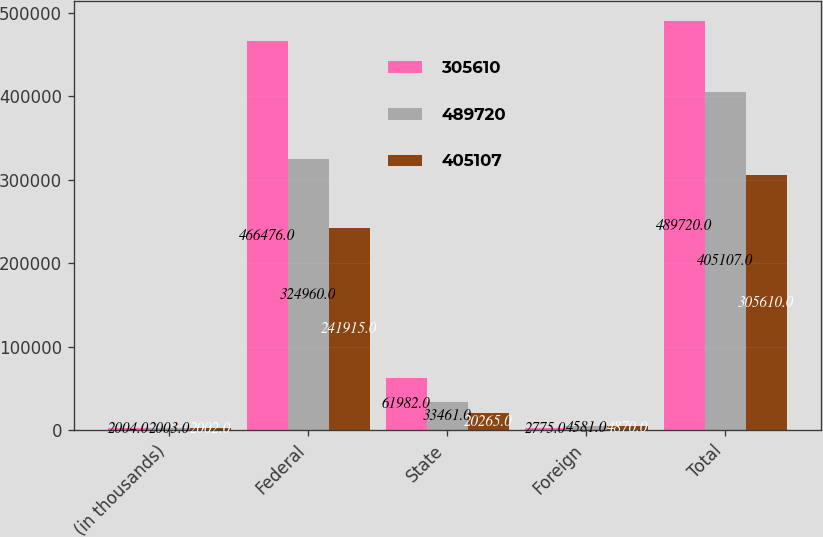Convert chart. <chart><loc_0><loc_0><loc_500><loc_500><stacked_bar_chart><ecel><fcel>(in thousands)<fcel>Federal<fcel>State<fcel>Foreign<fcel>Total<nl><fcel>305610<fcel>2004<fcel>466476<fcel>61982<fcel>2775<fcel>489720<nl><fcel>489720<fcel>2003<fcel>324960<fcel>33461<fcel>4581<fcel>405107<nl><fcel>405107<fcel>2002<fcel>241915<fcel>20265<fcel>4870<fcel>305610<nl></chart> 